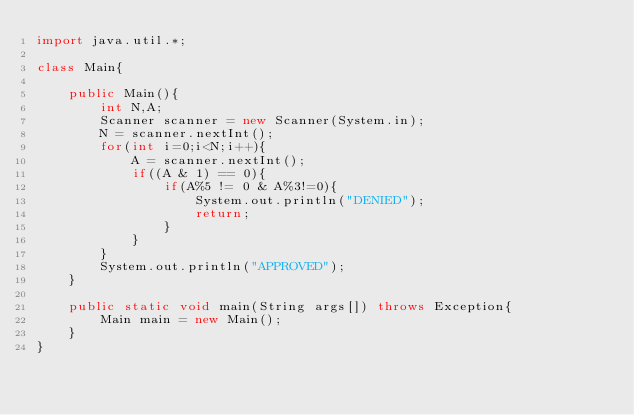<code> <loc_0><loc_0><loc_500><loc_500><_Java_>import java.util.*;

class Main{

    public Main(){
        int N,A;
        Scanner scanner = new Scanner(System.in);
        N = scanner.nextInt();
        for(int i=0;i<N;i++){
            A = scanner.nextInt();
            if((A & 1) == 0){
                if(A%5 != 0 & A%3!=0){
                    System.out.println("DENIED");
                    return;
                }
            }
        }
        System.out.println("APPROVED");
    }

    public static void main(String args[]) throws Exception{
        Main main = new Main();
    }
}
</code> 